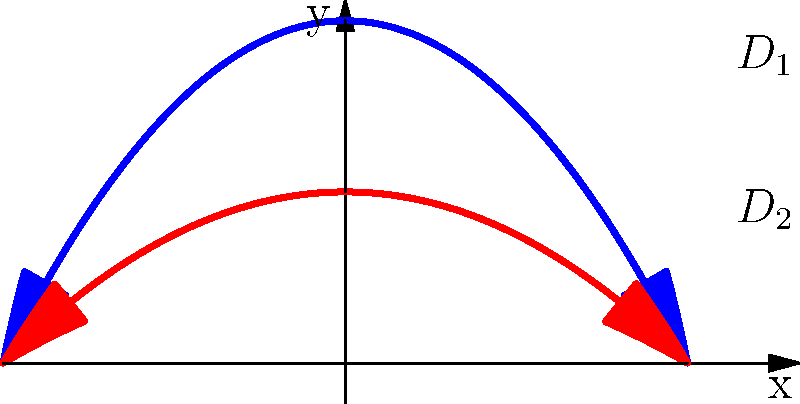Consider a fluid flowing through a pipe with a varying diameter. The velocity profiles at two different cross-sections, $D_1$ and $D_2$, are shown in the graph. The blue curve represents the velocity profile at $D_1$, and the red curve represents the velocity profile at $D_2$. Both profiles can be described by the equation $v(r) = v_{max}(1 - (\frac{r}{R})^2)$, where $v_{max}$ is the maximum velocity at the center of the pipe, $r$ is the radial distance from the center, and $R$ is the pipe radius. Given that the flow rate remains constant throughout the pipe, what is the ratio of the maximum velocities $\frac{v_{max2}}{v_{max1}}$? To solve this problem, we'll follow these steps:

1) First, recall that for a constant flow rate, the volumetric flow rate $Q$ must be the same at both cross-sections:

   $Q_1 = Q_2$

2) The volumetric flow rate for a circular pipe with a parabolic velocity profile is given by:

   $Q = \frac{\pi R^2 v_{max}}{2}$

3) Applying this to both cross-sections:

   $\frac{\pi R_1^2 v_{max1}}{2} = \frac{\pi R_2^2 v_{max2}}{2}$

4) From the graph, we can see that the radius of $D_2$ is half that of $D_1$:

   $R_2 = \frac{1}{2}R_1$

5) Substituting this into our equation:

   $\frac{\pi R_1^2 v_{max1}}{2} = \frac{\pi (\frac{1}{2}R_1)^2 v_{max2}}{2}$

6) Simplifying:

   $R_1^2 v_{max1} = \frac{1}{4}R_1^2 v_{max2}$

7) Cancelling $R_1^2$ from both sides:

   $v_{max1} = \frac{1}{4}v_{max2}$

8) Rearranging to find the ratio $\frac{v_{max2}}{v_{max1}}$:

   $\frac{v_{max2}}{v_{max1}} = 4$

Therefore, the maximum velocity at $D_2$ is 4 times the maximum velocity at $D_1$.
Answer: 4 